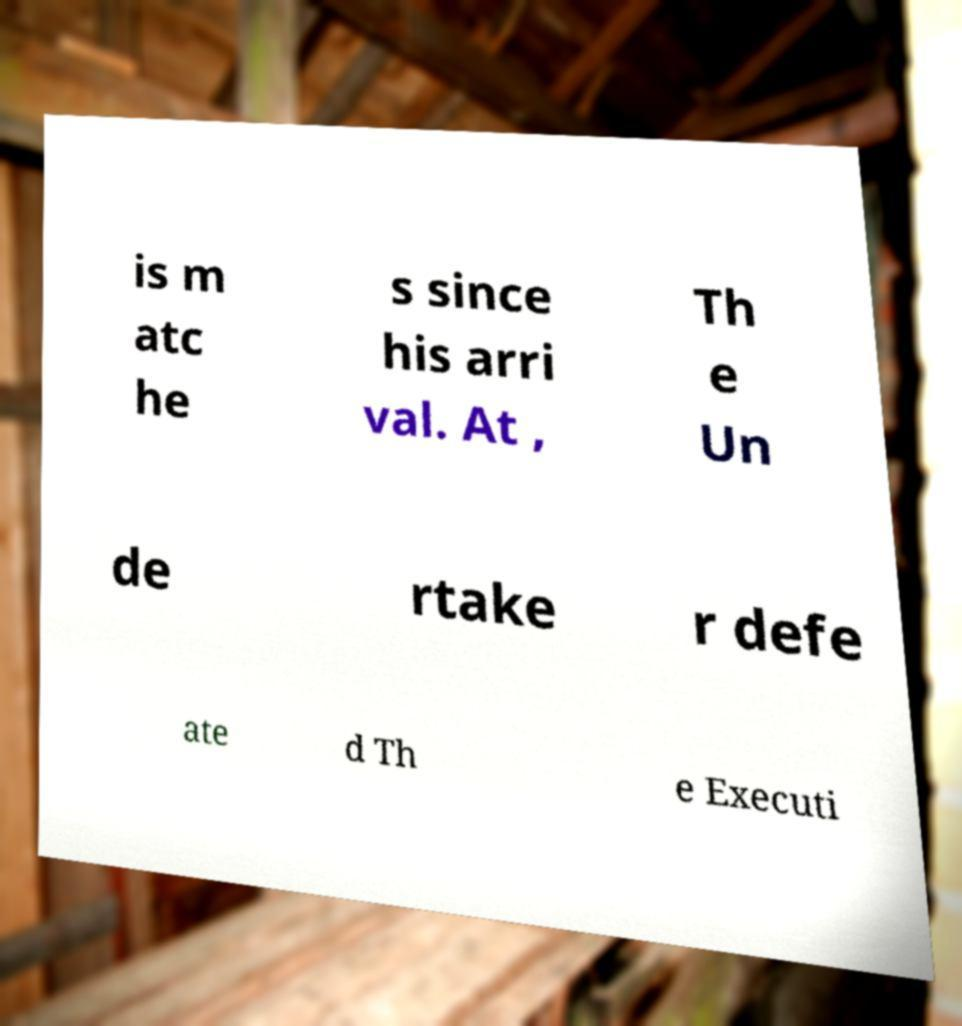There's text embedded in this image that I need extracted. Can you transcribe it verbatim? is m atc he s since his arri val. At , Th e Un de rtake r defe ate d Th e Executi 